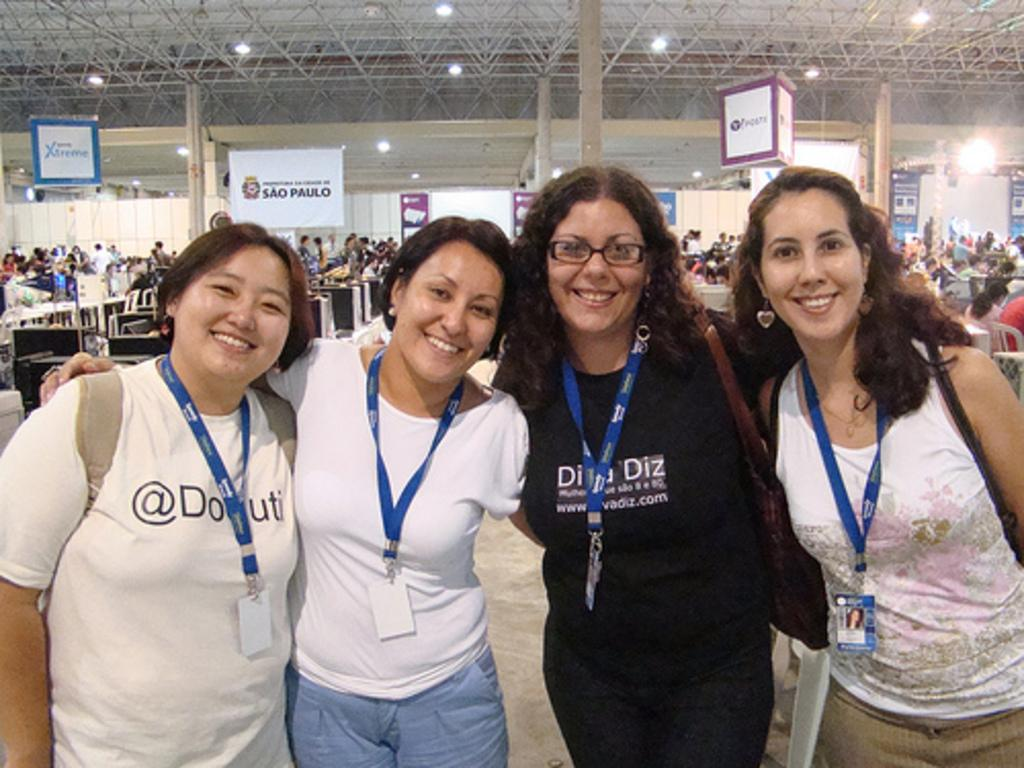Provide a one-sentence caption for the provided image. a banner that says sal paulo hangs in the background. 